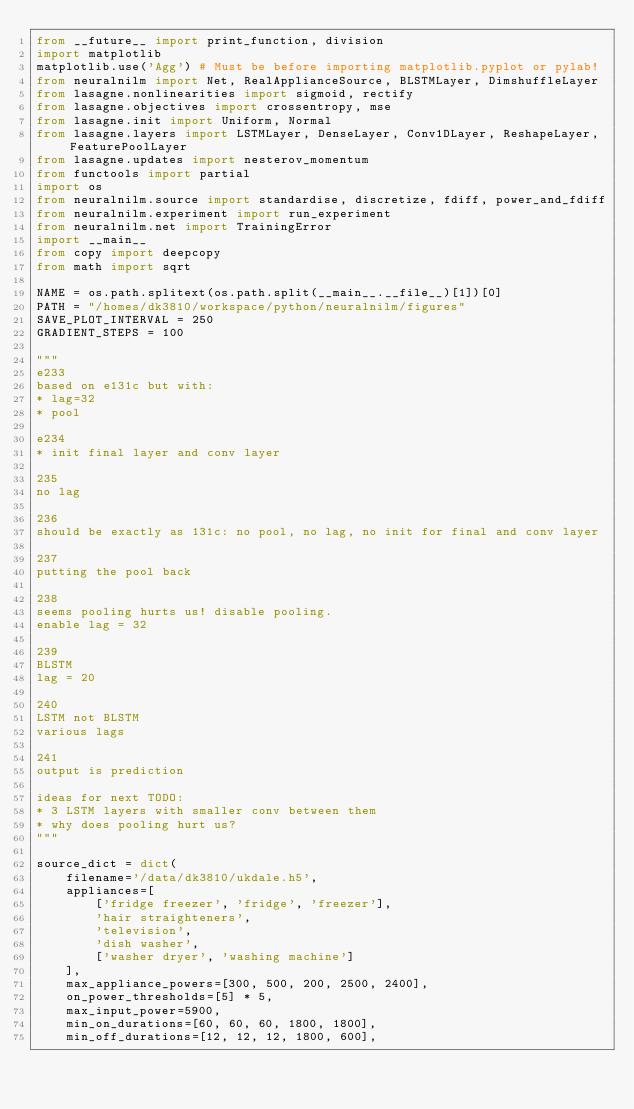<code> <loc_0><loc_0><loc_500><loc_500><_Python_>from __future__ import print_function, division
import matplotlib
matplotlib.use('Agg') # Must be before importing matplotlib.pyplot or pylab!
from neuralnilm import Net, RealApplianceSource, BLSTMLayer, DimshuffleLayer
from lasagne.nonlinearities import sigmoid, rectify
from lasagne.objectives import crossentropy, mse
from lasagne.init import Uniform, Normal
from lasagne.layers import LSTMLayer, DenseLayer, Conv1DLayer, ReshapeLayer, FeaturePoolLayer
from lasagne.updates import nesterov_momentum
from functools import partial
import os
from neuralnilm.source import standardise, discretize, fdiff, power_and_fdiff
from neuralnilm.experiment import run_experiment
from neuralnilm.net import TrainingError
import __main__
from copy import deepcopy
from math import sqrt

NAME = os.path.splitext(os.path.split(__main__.__file__)[1])[0]
PATH = "/homes/dk3810/workspace/python/neuralnilm/figures"
SAVE_PLOT_INTERVAL = 250
GRADIENT_STEPS = 100

"""
e233
based on e131c but with:
* lag=32
* pool

e234
* init final layer and conv layer

235
no lag

236
should be exactly as 131c: no pool, no lag, no init for final and conv layer

237
putting the pool back

238
seems pooling hurts us! disable pooling.
enable lag = 32

239
BLSTM
lag = 20

240
LSTM not BLSTM
various lags

241
output is prediction

ideas for next TODO:
* 3 LSTM layers with smaller conv between them
* why does pooling hurt us?
"""

source_dict = dict(
    filename='/data/dk3810/ukdale.h5',
    appliances=[
        ['fridge freezer', 'fridge', 'freezer'], 
        'hair straighteners', 
        'television',
        'dish washer',
        ['washer dryer', 'washing machine']
    ],
    max_appliance_powers=[300, 500, 200, 2500, 2400],
    on_power_thresholds=[5] * 5,
    max_input_power=5900,
    min_on_durations=[60, 60, 60, 1800, 1800],
    min_off_durations=[12, 12, 12, 1800, 600],</code> 